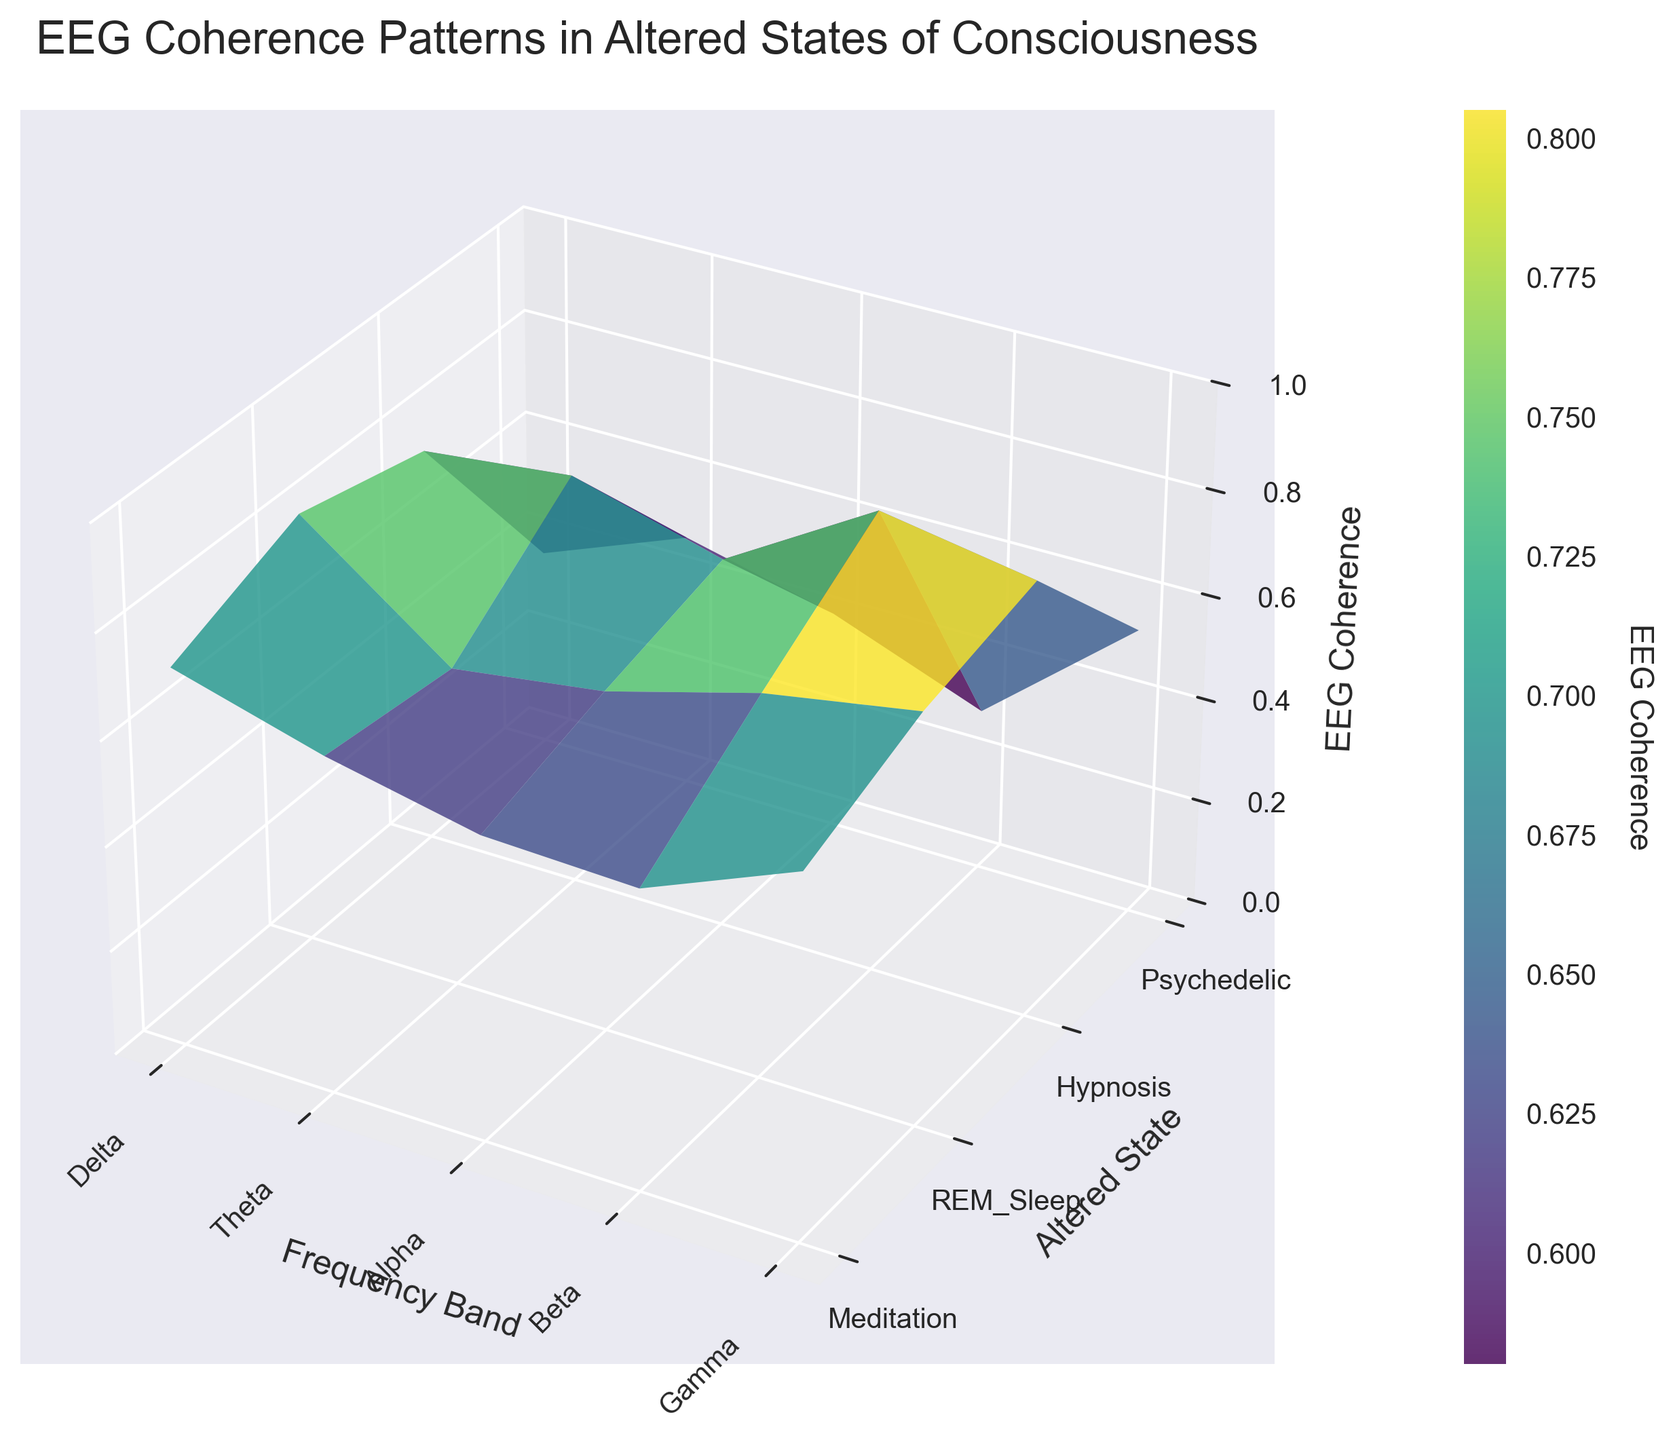What is the title of the plot? The title is usually placed at the top of the figure and describes the content of the plot. In this case, it reads "EEG Coherence Patterns in Altered States of Consciousness".
Answer: EEG Coherence Patterns in Altered States of Consciousness Which frequency band shows the highest EEG coherence during the Psychedelic state? Look at the 'Psychedelic' row and identify the frequency band with the highest peak on the 'Z' axis. Gamma has the highest value, which is 0.88.
Answer: Gamma What is the range of values on the z-axis (EEG Coherence)? The z-axis range is indicated by the z-limits shown in the plot. Here, it ranges from 0 to 1.
Answer: 0 to 1 Which altered state shows the lowest EEG coherence in the Alpha frequency band? In the 'Alpha' column, find the minimum value and check which altered state it corresponds to. REM Sleep has the lowest value at 0.38.
Answer: REM Sleep What is the average EEG coherence value for the Theta frequency band across all altered states? Locate the Theta column, sum the values (0.78 + 0.55 + 0.69 + 0.83), and then divide by the number of altered states (4). (0.78 + 0.55 + 0.69 + 0.83) / 4 = 2.85 / 4.
Answer: 0.7125 In which altered state is the Beta EEG coherence value higher: Hypnosis or Meditation? Compare the Beta values for Hypnosis (0.64) and Meditation (0.61) and note that Hypnosis has a higher value.
Answer: Hypnosis Which frequency band has the smallest discrepancy in EEG coherence between Meditation and REM Sleep? Calculate the absolute differences for all frequency bands between Meditation and REM Sleep, then identify the smallest one. Differences: Delta (0.65 - 0.42 = 0.23), Theta (0.78 - 0.55 = 0.23), Alpha (0.82 - 0.38 = 0.44), Beta (0.61 - 0.49 = 0.12), Gamma (0.73 - 0.31 = 0.42). The smallest discrepancy is in the Beta band.
Answer: Beta Which combination of altered state and frequency band has the maximum EEG coherence value in the plot? Identify the highest peak on the 3D surface plot. The maximum value is in the 'Gamma' frequency band and the 'Psychedelic' altered state, which is 0.88
Answer: Gamma-Psychedelic Which frequency band exhibits the largest variation in EEG coherence values among all altered states? Calculate the range (max-min) for each frequency band and find the largest one. Delta (0.71 - 0.42 = 0.29), Theta (0.83 - 0.55 = 0.28), Alpha (0.82 - 0.38 = 0.44), Beta (0.79 - 0.49 = 0.30), Gamma (0.88 - 0.31 = 0.57). The largest variation is in the Gamma band.
Answer: Gamma How does the EEG coherence for Hypnosis compare to REM Sleep across all frequency bands? List the EEG coherence values for Hypnosis and REM Sleep, and compare them for each frequency band: Delta (0.58 vs. 0.42), Theta (0.69 vs. 0.55), Alpha (0.72 vs. 0.38), Beta (0.64 vs. 0.49), Gamma (0.57 vs. 0.31). In each band, Hypnosis has higher coherence than REM Sleep.
Answer: Higher in all bands 